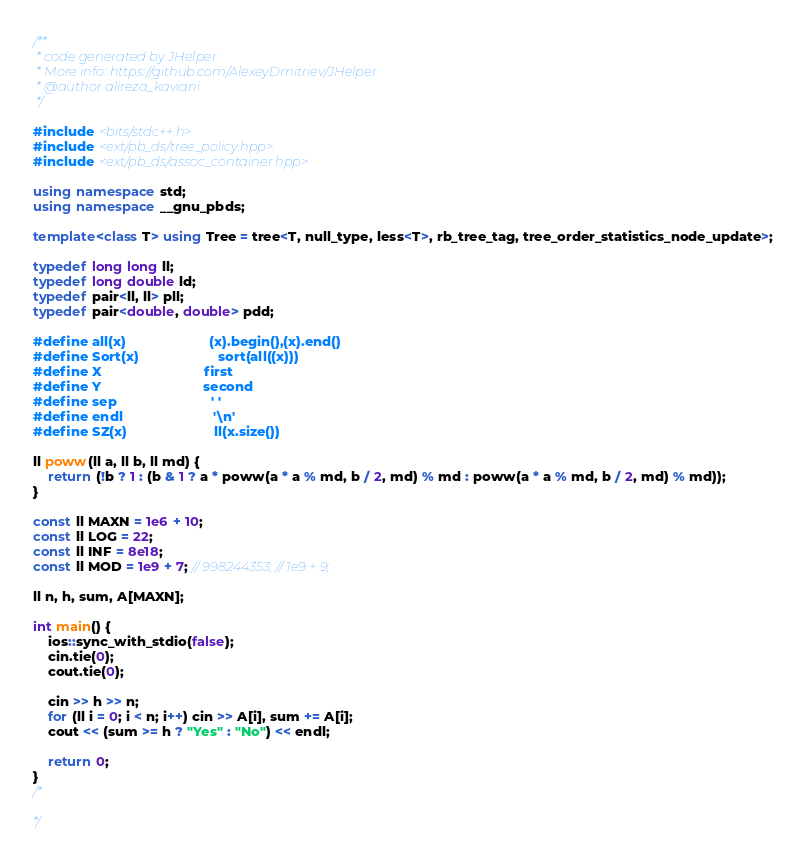<code> <loc_0><loc_0><loc_500><loc_500><_C++_>/**
 * code generated by JHelper
 * More info: https://github.com/AlexeyDmitriev/JHelper
 * @author alireza_kaviani
 */

#include <bits/stdc++.h>
#include <ext/pb_ds/tree_policy.hpp>
#include <ext/pb_ds/assoc_container.hpp>

using namespace std;
using namespace __gnu_pbds;

template<class T> using Tree = tree<T, null_type, less<T>, rb_tree_tag, tree_order_statistics_node_update>;

typedef long long ll;
typedef long double ld;
typedef pair<ll, ll> pll;
typedef pair<double, double> pdd;

#define all(x)                      (x).begin(),(x).end()
#define Sort(x)                     sort(all((x)))
#define X                           first
#define Y                           second
#define sep                         ' '
#define endl                        '\n'
#define SZ(x)                       ll(x.size())

ll poww(ll a, ll b, ll md) {
    return (!b ? 1 : (b & 1 ? a * poww(a * a % md, b / 2, md) % md : poww(a * a % md, b / 2, md) % md));
}

const ll MAXN = 1e6 + 10;
const ll LOG = 22;
const ll INF = 8e18;
const ll MOD = 1e9 + 7; // 998244353; // 1e9 + 9;

ll n, h, sum, A[MAXN];

int main() {
    ios::sync_with_stdio(false);
    cin.tie(0);
    cout.tie(0);

    cin >> h >> n;
    for (ll i = 0; i < n; i++) cin >> A[i], sum += A[i];
    cout << (sum >= h ? "Yes" : "No") << endl;

    return 0;
}
/*

*/
</code> 